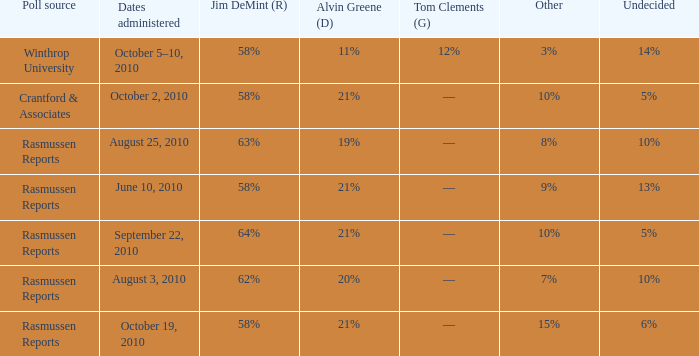Which poll source determined undecided of 5% and Jim DeMint (R) of 58%? Crantford & Associates. 